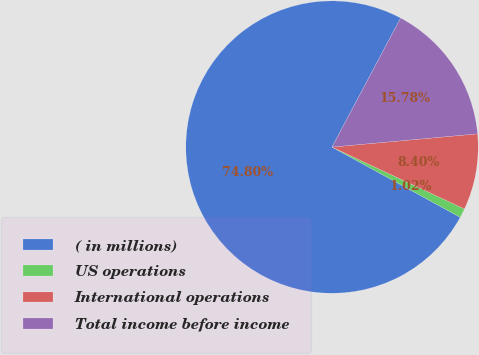<chart> <loc_0><loc_0><loc_500><loc_500><pie_chart><fcel>( in millions)<fcel>US operations<fcel>International operations<fcel>Total income before income<nl><fcel>74.8%<fcel>1.02%<fcel>8.4%<fcel>15.78%<nl></chart> 